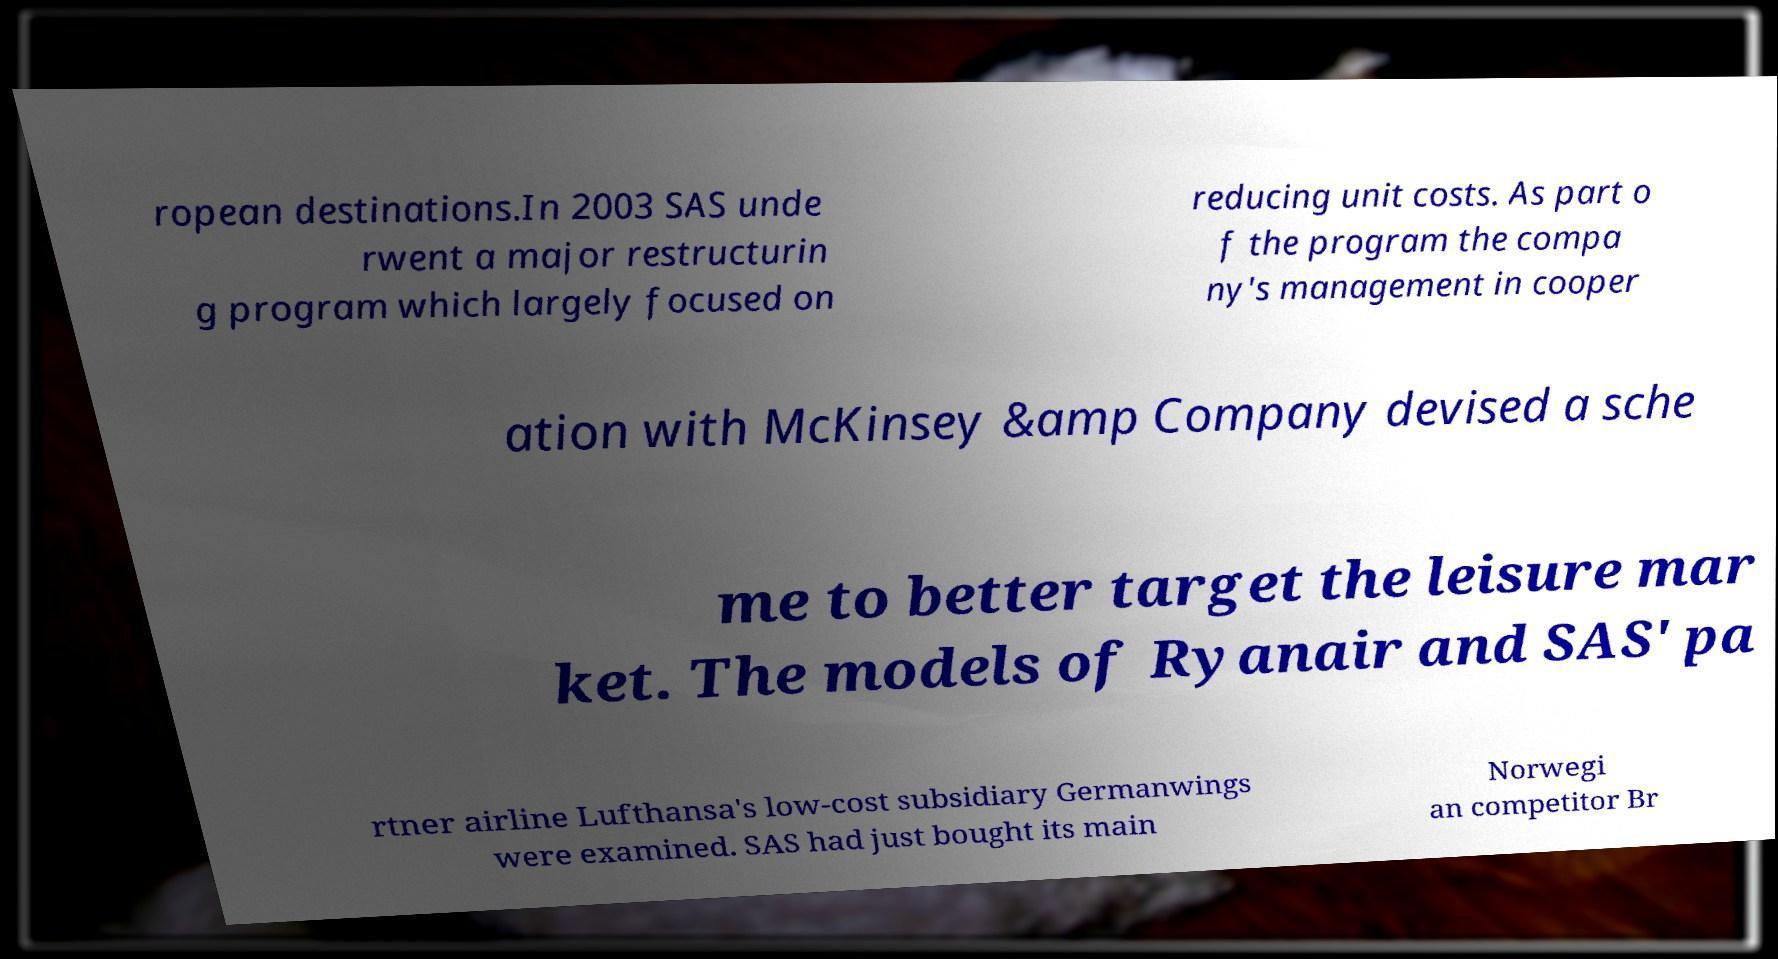Please read and relay the text visible in this image. What does it say? ropean destinations.In 2003 SAS unde rwent a major restructurin g program which largely focused on reducing unit costs. As part o f the program the compa ny's management in cooper ation with McKinsey &amp Company devised a sche me to better target the leisure mar ket. The models of Ryanair and SAS' pa rtner airline Lufthansa's low-cost subsidiary Germanwings were examined. SAS had just bought its main Norwegi an competitor Br 